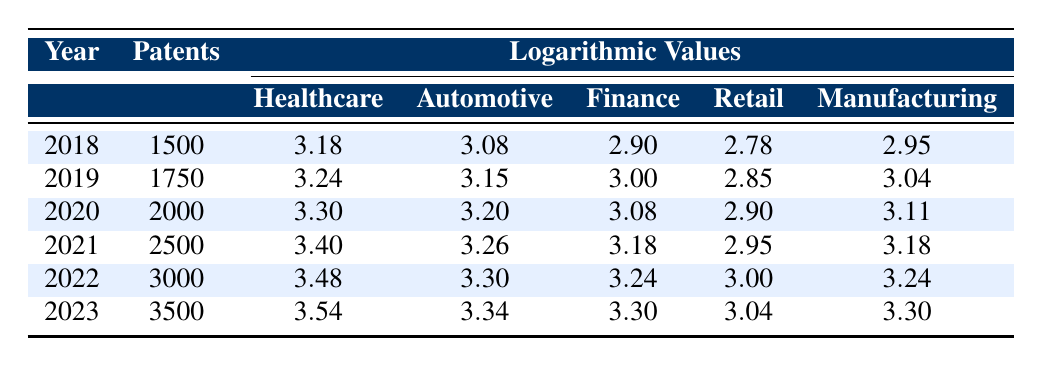What was the total number of AI-related patents filed in the healthcare sector from 2018 to 2022? The number of patents filed in healthcare for the years 2018, 2019, 2020, 2021, and 2022 are respectively 1500, 1750, 2000, 2500, and 3000. Adding these values: 1500 + 1750 + 2000 + 2500 + 3000 = 10750.
Answer: 10750 What is the logarithmic value of AI-related patents filed in the automotive sector in the year 2021? In the year 2021, the number of patents filed in the automotive sector is 1800. The corresponding logarithmic value shown in the table is 3.26.
Answer: 3.26 Did the number of AI-related patents in the finance sector increase every year from 2018 to 2023? The number of patents in the finance sector for the years are: 800 (2018), 1000 (2019), 1200 (2020), 1500 (2021), 1750 (2022), and 2000 (2023), which shows an increase each year.
Answer: Yes What was the percentage increase in AI-related patents filed in the retail sector from 2018 to 2023? The number of patents filed in the retail sector in 2018 was 600, and in 2023 it was 1100. The percentage increase can be calculated using the formula: ((1100 - 600) / 600) * 100 = 83.33%.
Answer: 83.33% Which sector had the highest logarithmic value of patent filings in 2023, and what was that value? In 2023, the logarithmic values for each sector are: Healthcare (3.54), Automotive (3.34), Finance (3.30), Retail (3.04), and Manufacturing (3.30). The highest value is 3.54 in the healthcare sector.
Answer: Healthcare, 3.54 What was the average number of AI-related patents filed in the manufacturing sector for the years 2018 to 2023? The numbers of patents filed in the manufacturing sector for those years are: 900 (2018), 1100 (2019), 1300 (2020), 1500 (2021), 1750 (2022), and 2000 (2023). To find the average, sum these values: 900 + 1100 + 1300 + 1500 + 1750 + 2000 = 10250, then divide by 6, which equals 1708.33.
Answer: 1708.33 Is there a year where the number of healthcare patents filed is less than that of automotive patents? Referring to the years listed, the healthcare patents are: 1500, 1750, 2000, 2500, 3000, and 3500 and automotive patents are 1200, 1400, 1600, 1800, 2000, and 2200. Healthcare patents exceed automotive patents every year in the given data.
Answer: No 